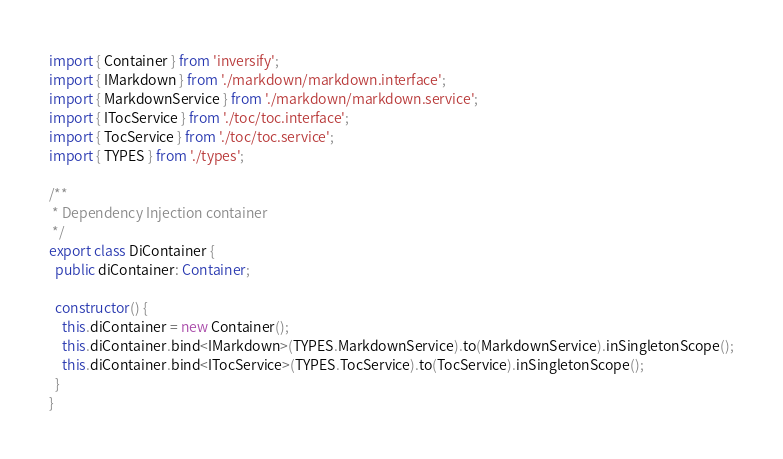<code> <loc_0><loc_0><loc_500><loc_500><_TypeScript_>import { Container } from 'inversify';
import { IMarkdown } from './markdown/markdown.interface';
import { MarkdownService } from './markdown/markdown.service';
import { ITocService } from './toc/toc.interface';
import { TocService } from './toc/toc.service';
import { TYPES } from './types';

/**
 * Dependency Injection container
 */
export class DiContainer {
  public diContainer: Container;

  constructor() {
    this.diContainer = new Container();
    this.diContainer.bind<IMarkdown>(TYPES.MarkdownService).to(MarkdownService).inSingletonScope();
    this.diContainer.bind<ITocService>(TYPES.TocService).to(TocService).inSingletonScope();
  }
}
</code> 